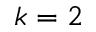Convert formula to latex. <formula><loc_0><loc_0><loc_500><loc_500>k = 2</formula> 